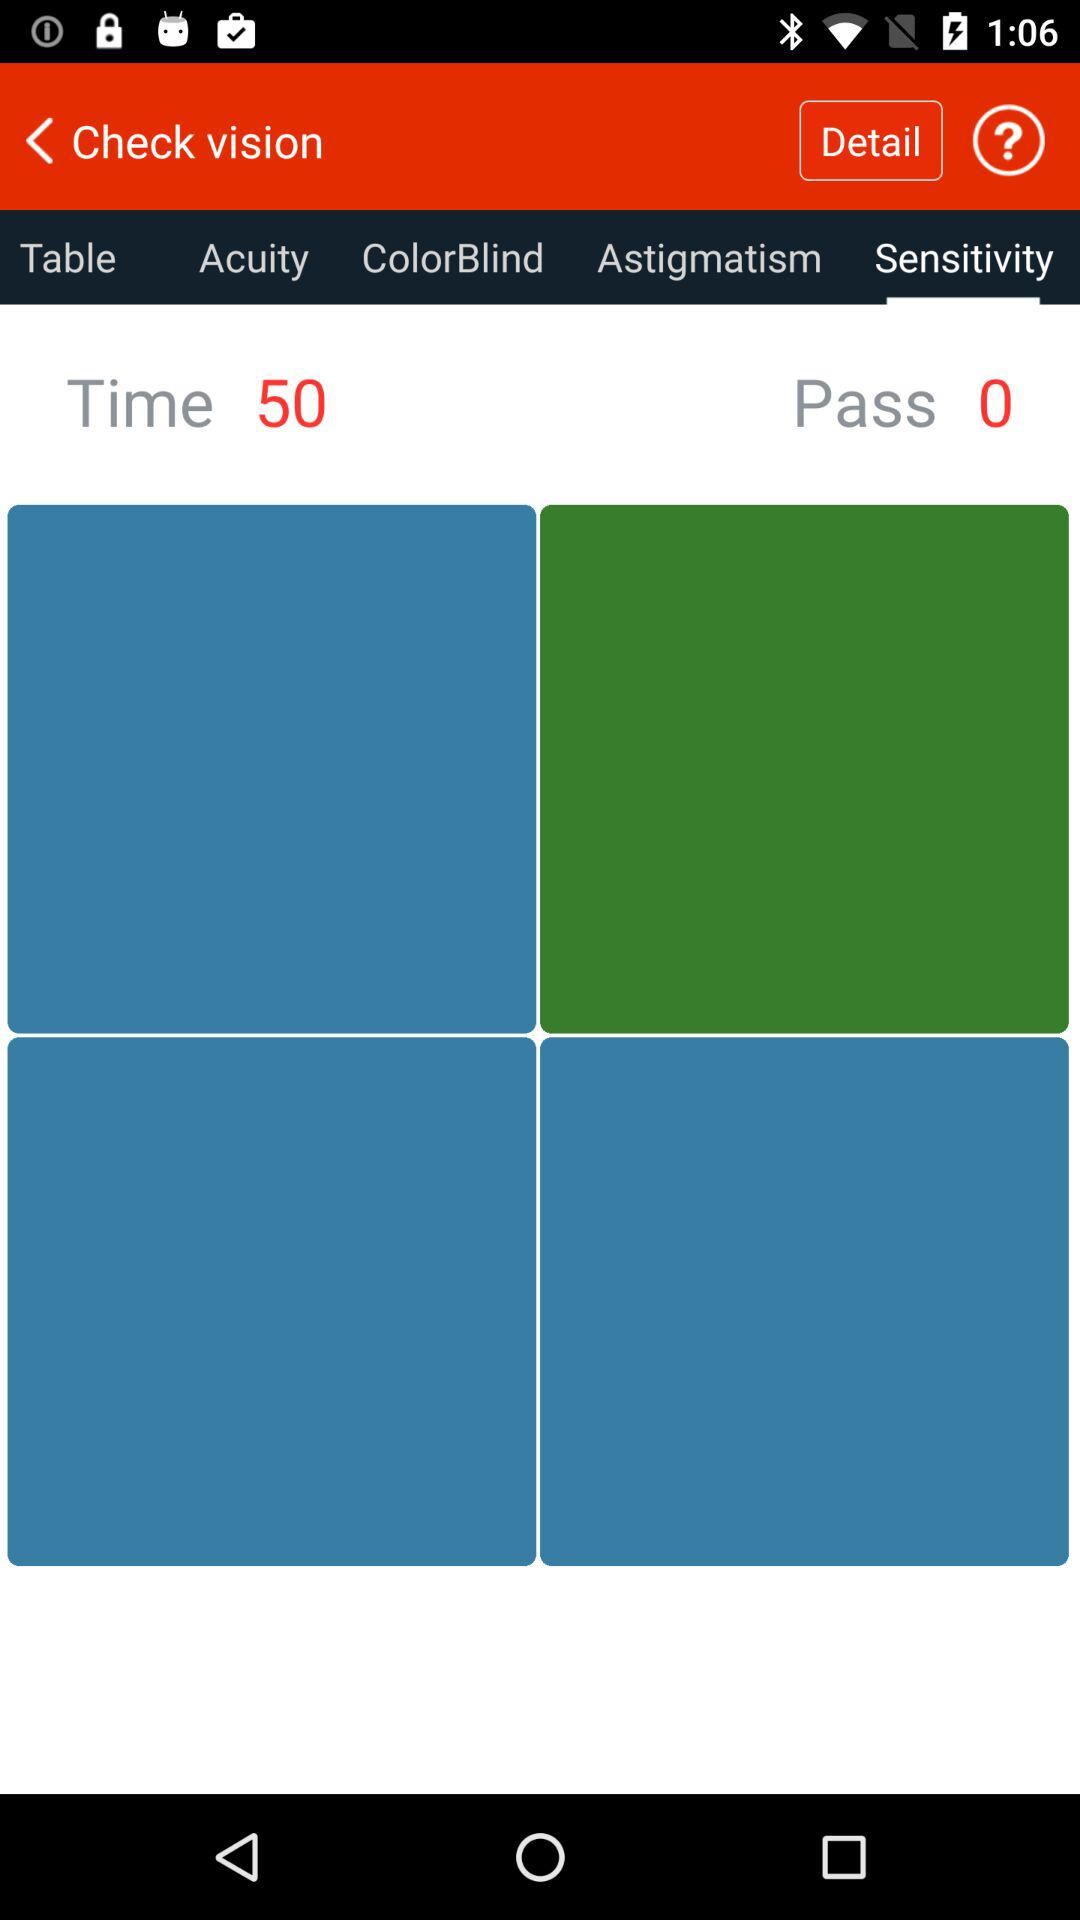How many times was the vision checked? The vision was checked 50 times. 